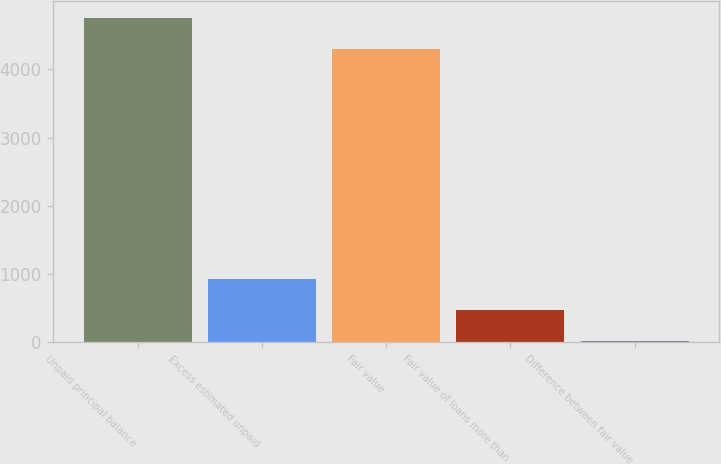<chart> <loc_0><loc_0><loc_500><loc_500><bar_chart><fcel>Unpaid principal balance<fcel>Excess estimated unpaid<fcel>Fair value<fcel>Fair value of loans more than<fcel>Difference between fair value<nl><fcel>4757.2<fcel>922.4<fcel>4304<fcel>469.2<fcel>16<nl></chart> 